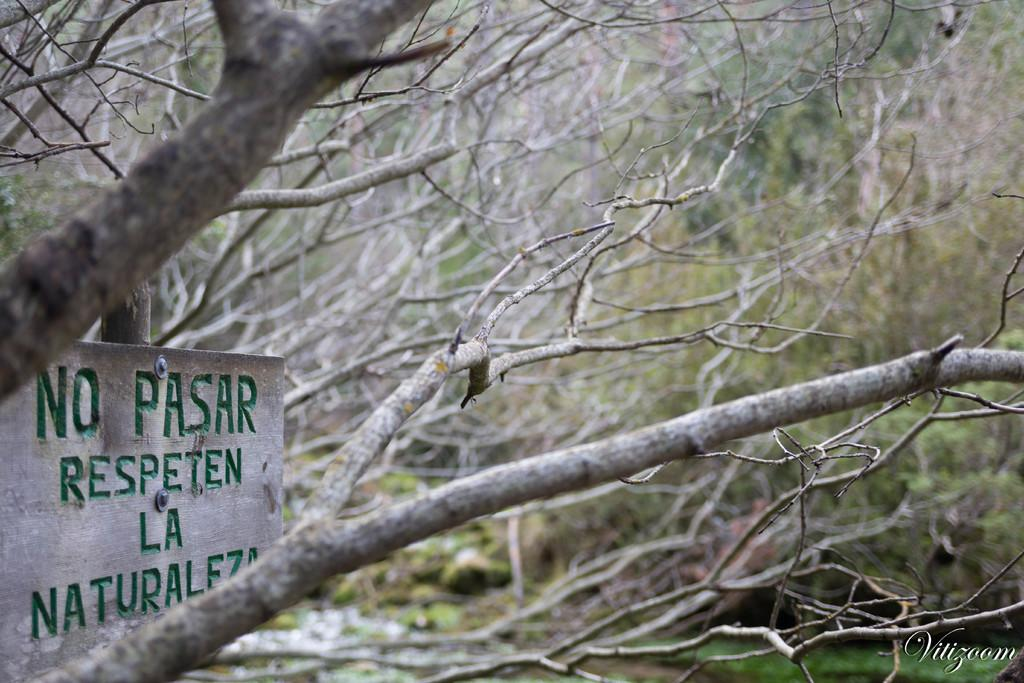What is the main object in the image? There is an information board in the image. What type of natural elements can be seen in the image? There are trees in the image. What is the surface that the information board and trees are standing on? The ground is visible in the image. What direction does the regret take in the image? There is no regret present in the image, so it cannot take any direction. 